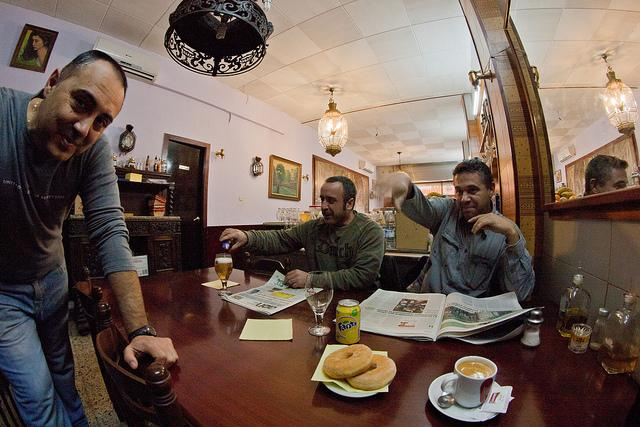How does the person in the image tell time? watch 